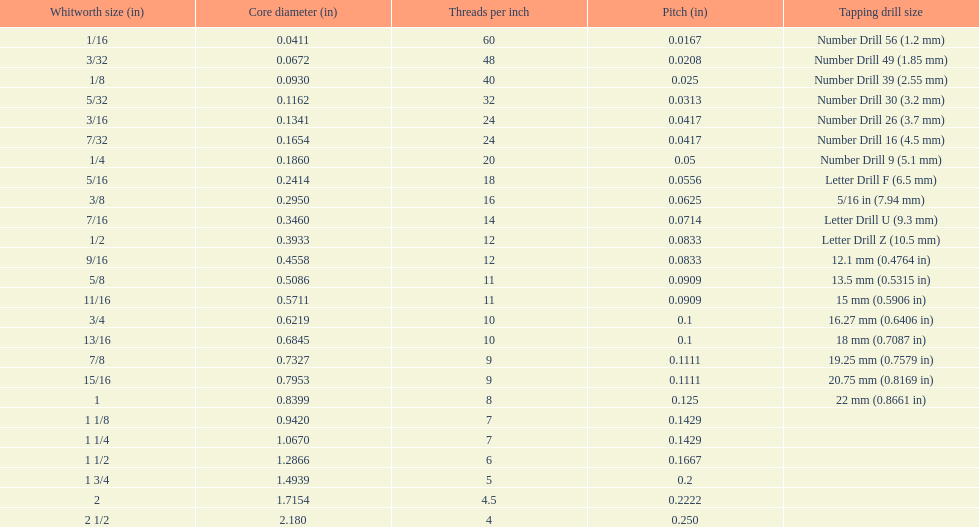What is the least core diameter (in)? 0.0411. 